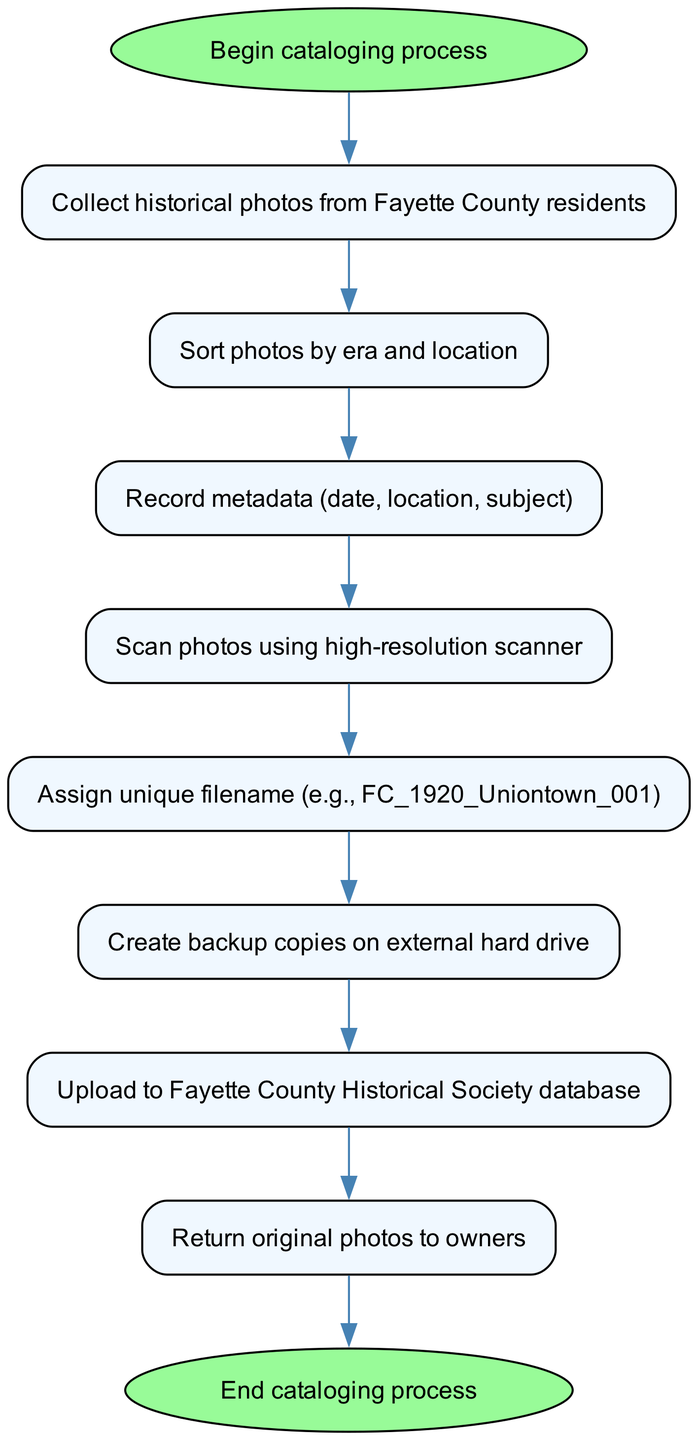What is the first step in the cataloging process? The first step is labeled as "Begin cataloging process," which indicates the initiation of the entire procedure for cataloging historical photographs.
Answer: Begin cataloging process How many total nodes are there in the diagram? Counting each individual step and the start and end nodes, there are ten nodes presented in the flow chart.
Answer: 10 What action follows the scanning of photos? The action that follows scanning is "Assign unique filename (e.g., FC_1920_Uniontown_001)", as indicated by the directed connection from the scanning node to the filename assignment node.
Answer: Assign unique filename Which node indicates the return of original photos? The return of the original photos to their owners is indicated by the node labeled "Return original photos to owners."
Answer: Return original photos to owners What is the last step in the cataloging process? The last step in the cataloging process is denoted by the node "End cataloging process," marking the conclusion of all activities related to this initiative.
Answer: End cataloging process If a historical photo is collected, how many steps do you need to go through before uploading it to the database? After the photo is collected, it must go through six steps in total: sorting, recording metadata, scanning, assigning a filename, creating a backup, and then uploading to the database.
Answer: 6 What type of document is created after assigning a filename? After assigning a filename, a document is not directly created; however, the step leads to "Create backup copies on external hard drive," which implies the digital file associated with the historical photo is stored.
Answer: Create backup copies Which node has the connection labeled 'upload'? The node that has the connection labeled 'upload' is "Upload to Fayette County Historical Society database," which signifies where the scanned files are ultimately sent.
Answer: Upload to Fayette County Historical Society database What type of action is taken immediately after sorting photos? Immediately after sorting photos, the action taken is "Record metadata (date, location, subject)," signifying a documentation step that follows sorting.
Answer: Record metadata 